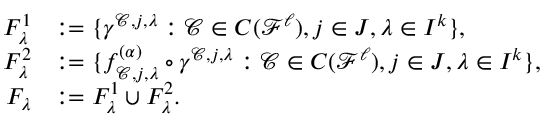<formula> <loc_0><loc_0><loc_500><loc_500>\begin{array} { r l } { F _ { \lambda } ^ { 1 } } & { \colon = \{ \gamma ^ { \mathcal { C } , j , \lambda } \colon \mathcal { C } \in C ( \ m a t h s c r { F } ^ { \ell } ) , j \in J , \lambda \in I ^ { k } \} , } \\ { F _ { \lambda } ^ { 2 } } & { \colon = \{ f _ { \mathcal { C } , j , \lambda } ^ { ( \alpha ) } \circ \gamma ^ { \mathcal { C } , j , \lambda } \colon \mathcal { C } \in C ( \ m a t h s c r { F } ^ { \ell } ) , j \in J , \lambda \in I ^ { k } \} , } \\ { F _ { \lambda } } & { \colon = F _ { \lambda } ^ { 1 } \cup F _ { \lambda } ^ { 2 } . } \end{array}</formula> 